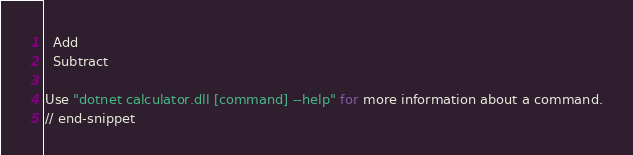Convert code to text. <code><loc_0><loc_0><loc_500><loc_500><_Bash_>
  Add
  Subtract

Use "dotnet calculator.dll [command] --help" for more information about a command.
// end-snippet</code> 